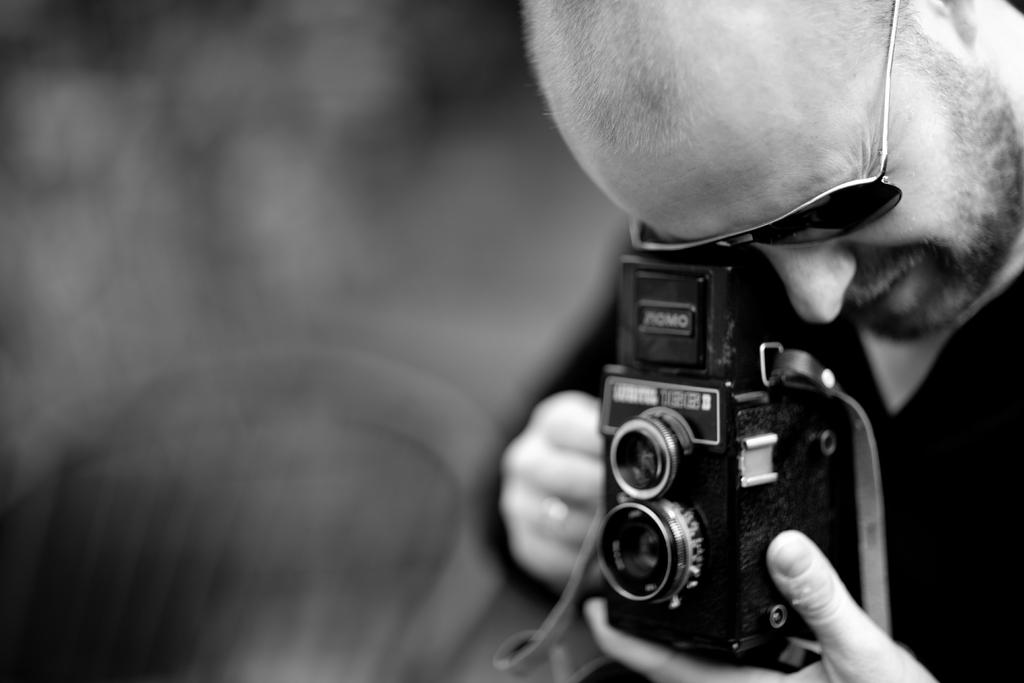What is the main subject of the image? The main subject of the image is a man. What is the man holding in his hand? The man is holding a camera in his hand. What type of produce is the man selling in the image? There is no produce present in the image; the man is holding a camera. What is the price of the camera the man is holding in the image? The price of the camera is not visible in the image, so it cannot be determined. 